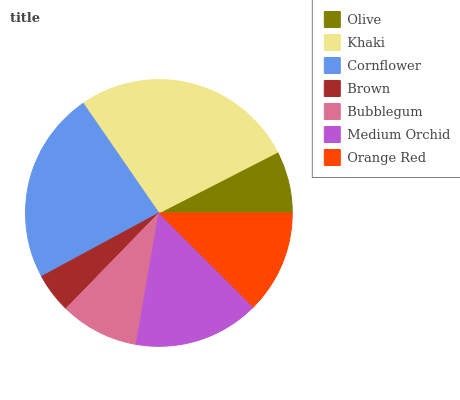Is Brown the minimum?
Answer yes or no. Yes. Is Khaki the maximum?
Answer yes or no. Yes. Is Cornflower the minimum?
Answer yes or no. No. Is Cornflower the maximum?
Answer yes or no. No. Is Khaki greater than Cornflower?
Answer yes or no. Yes. Is Cornflower less than Khaki?
Answer yes or no. Yes. Is Cornflower greater than Khaki?
Answer yes or no. No. Is Khaki less than Cornflower?
Answer yes or no. No. Is Orange Red the high median?
Answer yes or no. Yes. Is Orange Red the low median?
Answer yes or no. Yes. Is Olive the high median?
Answer yes or no. No. Is Khaki the low median?
Answer yes or no. No. 